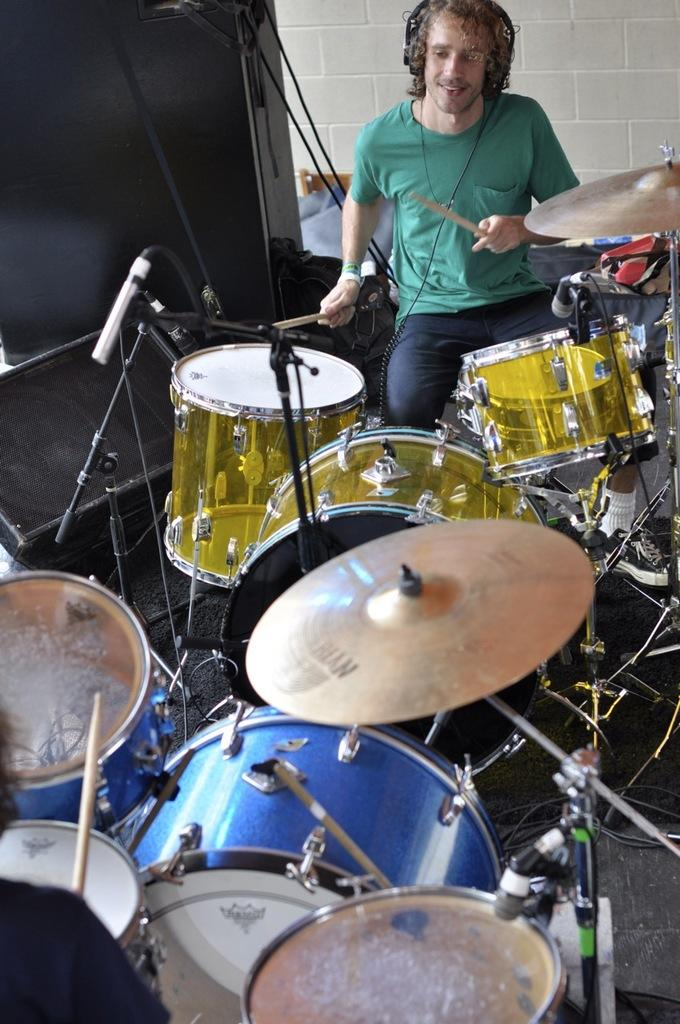What is the main subject of the image? The main subject of the image is a man. What is the man doing in the image? The man is sitting and playing a band. What can be seen in the background of the image? There is a wall in the background of the image. What is present at the bottom of the image? There are wires at the bottom of the image. How many pigs are visible in the image? There are no pigs present in the image. What type of ducks can be seen swimming in the background? There are no ducks present in the image. 